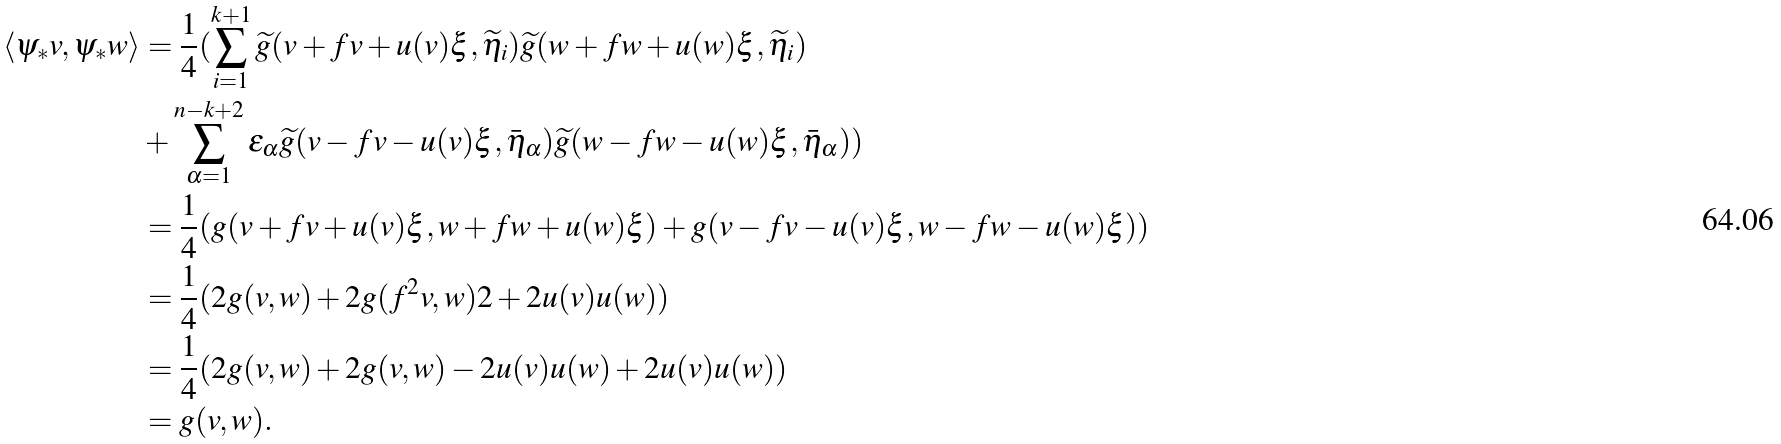Convert formula to latex. <formula><loc_0><loc_0><loc_500><loc_500>\langle \psi _ { * } v , \psi _ { * } w \rangle & = \frac { 1 } { 4 } ( \sum _ { i = 1 } ^ { k + 1 } \widetilde { g } ( v + f v + u ( v ) \xi , \widetilde { \eta } _ { i } ) \widetilde { g } ( w + f w + u ( w ) \xi , \widetilde { \eta } _ { i } ) \\ & + \sum _ { \alpha = 1 } ^ { n - k + 2 } \epsilon _ { \alpha } \widetilde { g } ( v - f v - u ( v ) \xi , \bar { \eta } _ { \alpha } ) \widetilde { g } ( w - f w - u ( w ) \xi , \bar { \eta } _ { \alpha } ) ) \\ & = \frac { 1 } { 4 } ( g ( v + f v + u ( v ) \xi , w + f w + u ( w ) \xi ) + g ( v - f v - u ( v ) \xi , w - f w - u ( w ) \xi ) ) \\ & = \frac { 1 } { 4 } ( 2 g ( v , w ) + 2 g ( f ^ { 2 } v , w ) 2 + 2 u ( v ) u ( w ) ) \\ & = \frac { 1 } { 4 } ( 2 g ( v , w ) + 2 g ( v , w ) - 2 u ( v ) u ( w ) + 2 u ( v ) u ( w ) ) \\ & = g ( v , w ) .</formula> 